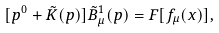<formula> <loc_0><loc_0><loc_500><loc_500>[ p ^ { 0 } + \tilde { K } ( p ) ] \tilde { B } _ { \mu } ^ { 1 } ( p ) = F [ f _ { \mu } ( x ) ] ,</formula> 